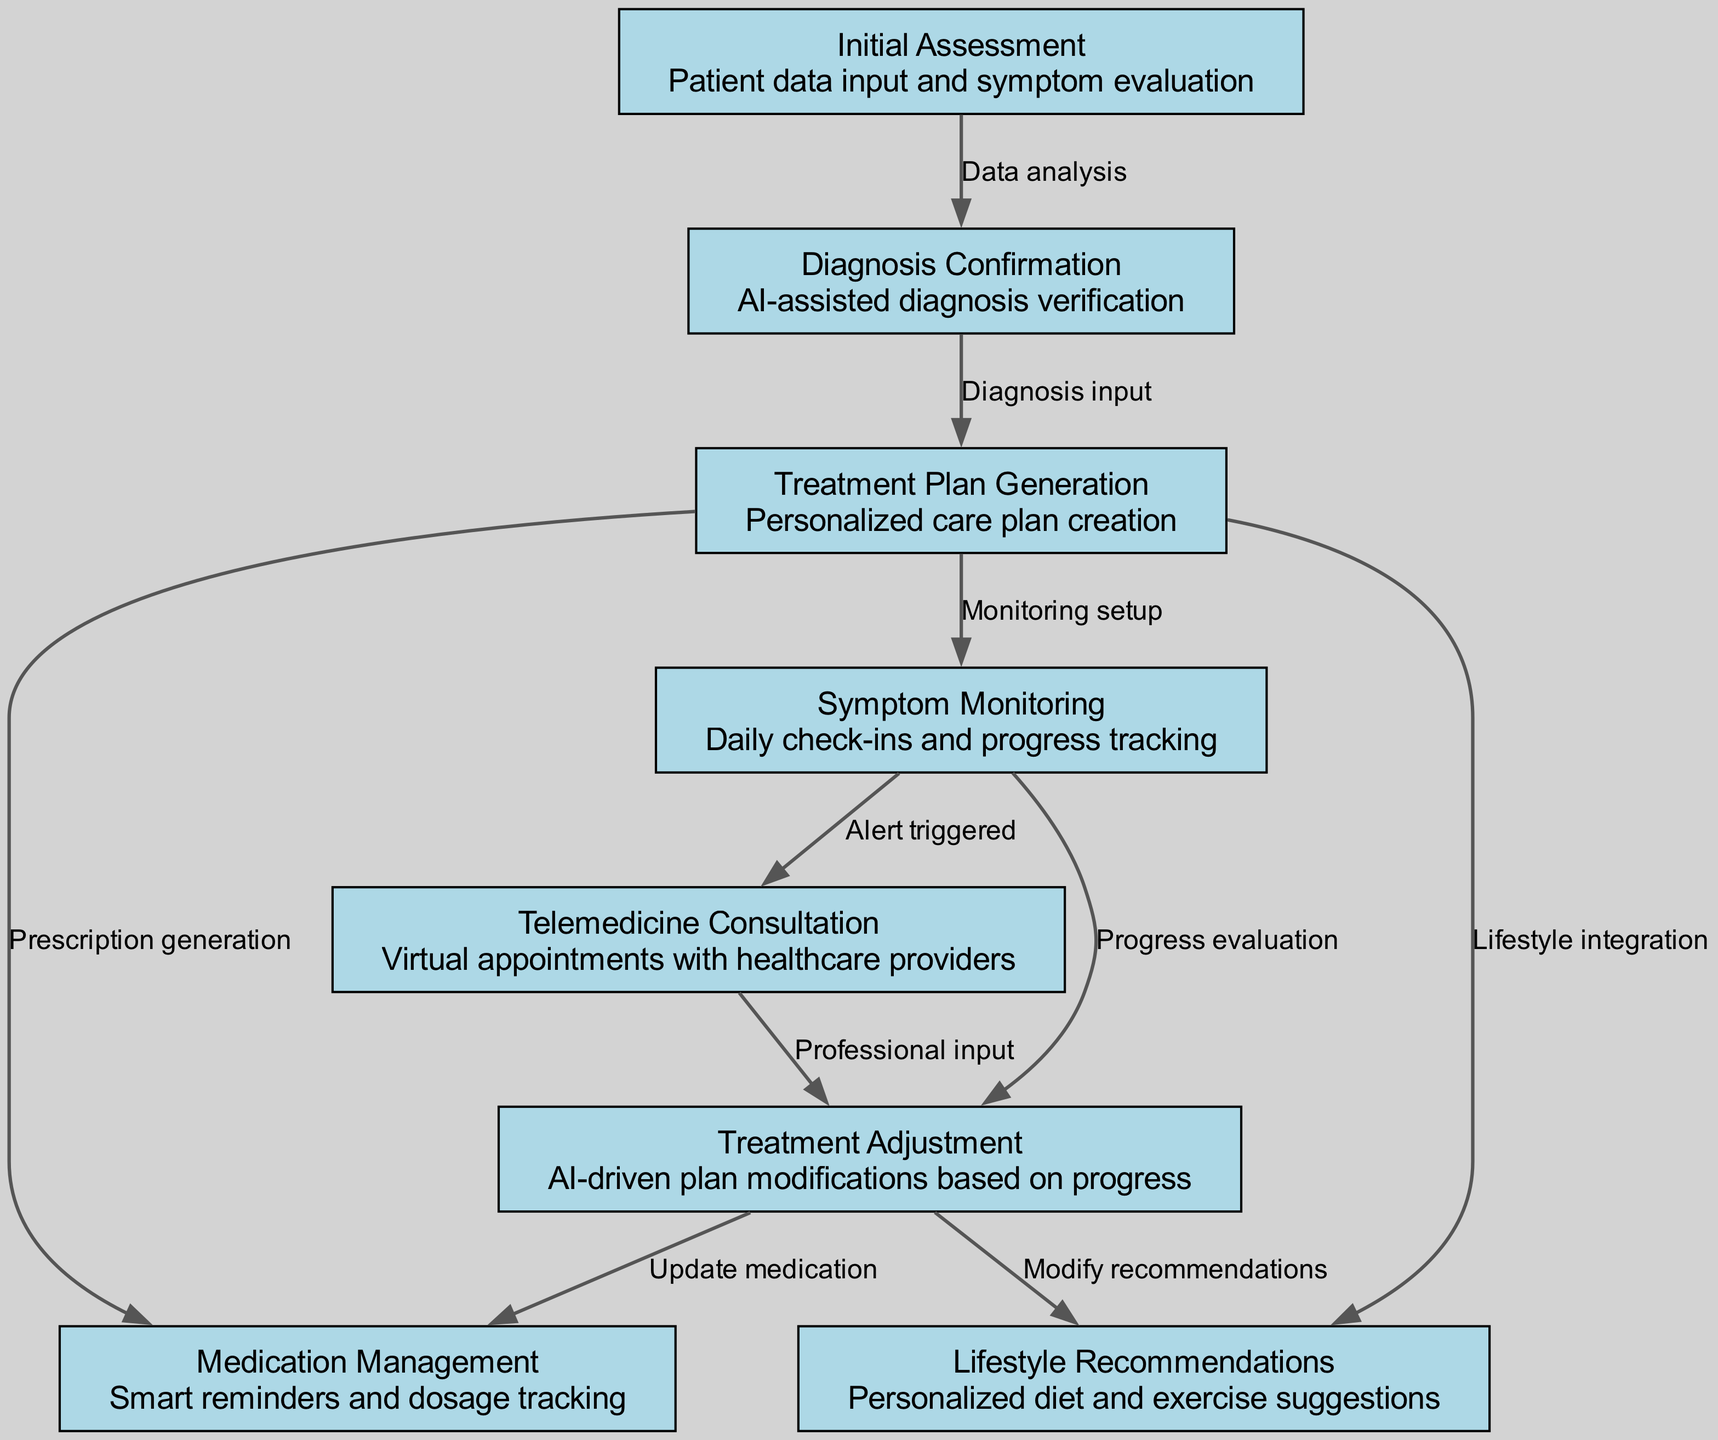What is the first step in the patient journey? The first node in the diagram is "Initial Assessment," which is where the patient data is input and symptoms are evaluated.
Answer: Initial Assessment How many nodes are present in the diagram? By counting each distinct step or stage in the patient journey, we see there are a total of eight nodes.
Answer: Eight What triggers the telemedicine consultation? The telemedicine consultation is triggered after "Symptom Monitoring," specifically when an alert is triggered from daily check-ins.
Answer: Alert triggered What is generated after the diagnosis confirmation? After the "Diagnosis Confirmation," the next step is "Treatment Plan Generation," which involves creating a personalized care plan.
Answer: Treatment Plan Generation Which step is responsible for modifying medication? The step responsible for modifying medication is "Treatment Adjustment," which updates the medication based on the patient's progress.
Answer: Treatment Adjustment What relationship exists between symptom monitoring and lifestyle recommendations? "Symptom Monitoring" leads to lifestyle recommendations via "Monitoring setup," indicating that progress tracking sets up the need for personalized diet and exercise suggestions.
Answer: Monitoring setup How many edges connect the nodes in the diagram? By counting every directed connection between nodes, we find that there are nine edges in total.
Answer: Nine Which node involves AI-assisted diagnosis verification? The node that involves AI-assisted diagnosis verification is "Diagnosis Confirmation," which comes immediately after the initial assessment.
Answer: Diagnosis Confirmation What is the final step in the intervention process? The final step in the intervention process is "Treatment Adjustment," which occurs after evaluations from symptom monitoring and telemedicine consultations.
Answer: Treatment Adjustment 